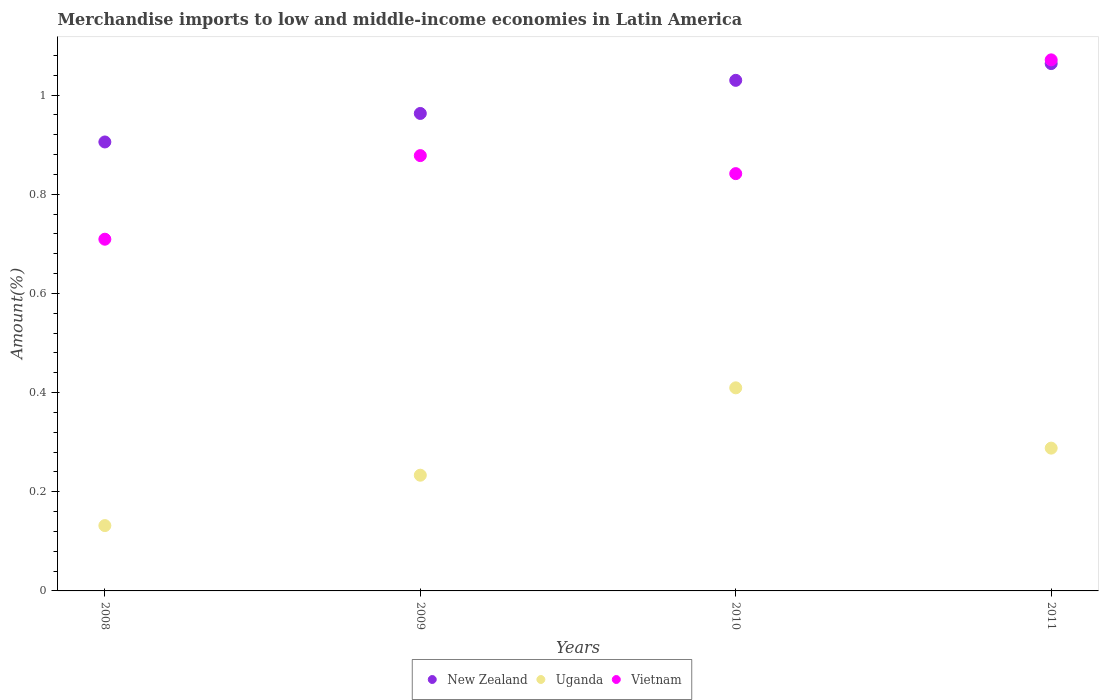Is the number of dotlines equal to the number of legend labels?
Keep it short and to the point. Yes. What is the percentage of amount earned from merchandise imports in Uganda in 2008?
Your answer should be very brief. 0.13. Across all years, what is the maximum percentage of amount earned from merchandise imports in New Zealand?
Keep it short and to the point. 1.06. Across all years, what is the minimum percentage of amount earned from merchandise imports in Vietnam?
Provide a short and direct response. 0.71. In which year was the percentage of amount earned from merchandise imports in New Zealand maximum?
Ensure brevity in your answer.  2011. In which year was the percentage of amount earned from merchandise imports in New Zealand minimum?
Ensure brevity in your answer.  2008. What is the total percentage of amount earned from merchandise imports in Uganda in the graph?
Provide a succinct answer. 1.06. What is the difference between the percentage of amount earned from merchandise imports in New Zealand in 2008 and that in 2009?
Offer a very short reply. -0.06. What is the difference between the percentage of amount earned from merchandise imports in Uganda in 2011 and the percentage of amount earned from merchandise imports in Vietnam in 2009?
Give a very brief answer. -0.59. What is the average percentage of amount earned from merchandise imports in New Zealand per year?
Your response must be concise. 0.99. In the year 2008, what is the difference between the percentage of amount earned from merchandise imports in Vietnam and percentage of amount earned from merchandise imports in Uganda?
Ensure brevity in your answer.  0.58. What is the ratio of the percentage of amount earned from merchandise imports in Uganda in 2009 to that in 2011?
Your answer should be very brief. 0.81. Is the difference between the percentage of amount earned from merchandise imports in Vietnam in 2008 and 2009 greater than the difference between the percentage of amount earned from merchandise imports in Uganda in 2008 and 2009?
Provide a short and direct response. No. What is the difference between the highest and the second highest percentage of amount earned from merchandise imports in Vietnam?
Offer a very short reply. 0.19. What is the difference between the highest and the lowest percentage of amount earned from merchandise imports in Uganda?
Your response must be concise. 0.28. In how many years, is the percentage of amount earned from merchandise imports in Uganda greater than the average percentage of amount earned from merchandise imports in Uganda taken over all years?
Ensure brevity in your answer.  2. Is the sum of the percentage of amount earned from merchandise imports in New Zealand in 2008 and 2010 greater than the maximum percentage of amount earned from merchandise imports in Vietnam across all years?
Your answer should be compact. Yes. Does the percentage of amount earned from merchandise imports in New Zealand monotonically increase over the years?
Provide a succinct answer. Yes. How many dotlines are there?
Ensure brevity in your answer.  3. How many years are there in the graph?
Ensure brevity in your answer.  4. What is the difference between two consecutive major ticks on the Y-axis?
Give a very brief answer. 0.2. Does the graph contain any zero values?
Ensure brevity in your answer.  No. Where does the legend appear in the graph?
Your answer should be compact. Bottom center. How many legend labels are there?
Provide a succinct answer. 3. What is the title of the graph?
Offer a terse response. Merchandise imports to low and middle-income economies in Latin America. Does "Congo (Democratic)" appear as one of the legend labels in the graph?
Keep it short and to the point. No. What is the label or title of the Y-axis?
Give a very brief answer. Amount(%). What is the Amount(%) in New Zealand in 2008?
Ensure brevity in your answer.  0.91. What is the Amount(%) of Uganda in 2008?
Give a very brief answer. 0.13. What is the Amount(%) in Vietnam in 2008?
Offer a terse response. 0.71. What is the Amount(%) of New Zealand in 2009?
Offer a very short reply. 0.96. What is the Amount(%) of Uganda in 2009?
Your answer should be very brief. 0.23. What is the Amount(%) in Vietnam in 2009?
Keep it short and to the point. 0.88. What is the Amount(%) of New Zealand in 2010?
Your answer should be compact. 1.03. What is the Amount(%) in Uganda in 2010?
Offer a terse response. 0.41. What is the Amount(%) in Vietnam in 2010?
Provide a short and direct response. 0.84. What is the Amount(%) of New Zealand in 2011?
Provide a short and direct response. 1.06. What is the Amount(%) of Uganda in 2011?
Give a very brief answer. 0.29. What is the Amount(%) in Vietnam in 2011?
Your response must be concise. 1.07. Across all years, what is the maximum Amount(%) in New Zealand?
Provide a short and direct response. 1.06. Across all years, what is the maximum Amount(%) of Uganda?
Your answer should be very brief. 0.41. Across all years, what is the maximum Amount(%) of Vietnam?
Provide a succinct answer. 1.07. Across all years, what is the minimum Amount(%) of New Zealand?
Offer a very short reply. 0.91. Across all years, what is the minimum Amount(%) of Uganda?
Your answer should be compact. 0.13. Across all years, what is the minimum Amount(%) of Vietnam?
Keep it short and to the point. 0.71. What is the total Amount(%) of New Zealand in the graph?
Your answer should be very brief. 3.96. What is the total Amount(%) in Uganda in the graph?
Your answer should be very brief. 1.06. What is the total Amount(%) of Vietnam in the graph?
Your answer should be compact. 3.5. What is the difference between the Amount(%) in New Zealand in 2008 and that in 2009?
Provide a succinct answer. -0.06. What is the difference between the Amount(%) in Uganda in 2008 and that in 2009?
Your answer should be compact. -0.1. What is the difference between the Amount(%) of Vietnam in 2008 and that in 2009?
Make the answer very short. -0.17. What is the difference between the Amount(%) of New Zealand in 2008 and that in 2010?
Offer a very short reply. -0.12. What is the difference between the Amount(%) of Uganda in 2008 and that in 2010?
Keep it short and to the point. -0.28. What is the difference between the Amount(%) of Vietnam in 2008 and that in 2010?
Make the answer very short. -0.13. What is the difference between the Amount(%) in New Zealand in 2008 and that in 2011?
Offer a terse response. -0.16. What is the difference between the Amount(%) in Uganda in 2008 and that in 2011?
Your answer should be compact. -0.16. What is the difference between the Amount(%) in Vietnam in 2008 and that in 2011?
Offer a terse response. -0.36. What is the difference between the Amount(%) of New Zealand in 2009 and that in 2010?
Provide a succinct answer. -0.07. What is the difference between the Amount(%) of Uganda in 2009 and that in 2010?
Give a very brief answer. -0.18. What is the difference between the Amount(%) in Vietnam in 2009 and that in 2010?
Keep it short and to the point. 0.04. What is the difference between the Amount(%) in New Zealand in 2009 and that in 2011?
Provide a short and direct response. -0.1. What is the difference between the Amount(%) of Uganda in 2009 and that in 2011?
Your response must be concise. -0.05. What is the difference between the Amount(%) of Vietnam in 2009 and that in 2011?
Offer a very short reply. -0.19. What is the difference between the Amount(%) of New Zealand in 2010 and that in 2011?
Give a very brief answer. -0.03. What is the difference between the Amount(%) in Uganda in 2010 and that in 2011?
Offer a terse response. 0.12. What is the difference between the Amount(%) of Vietnam in 2010 and that in 2011?
Your answer should be very brief. -0.23. What is the difference between the Amount(%) of New Zealand in 2008 and the Amount(%) of Uganda in 2009?
Keep it short and to the point. 0.67. What is the difference between the Amount(%) in New Zealand in 2008 and the Amount(%) in Vietnam in 2009?
Offer a terse response. 0.03. What is the difference between the Amount(%) of Uganda in 2008 and the Amount(%) of Vietnam in 2009?
Your response must be concise. -0.75. What is the difference between the Amount(%) of New Zealand in 2008 and the Amount(%) of Uganda in 2010?
Offer a very short reply. 0.5. What is the difference between the Amount(%) of New Zealand in 2008 and the Amount(%) of Vietnam in 2010?
Keep it short and to the point. 0.06. What is the difference between the Amount(%) in Uganda in 2008 and the Amount(%) in Vietnam in 2010?
Ensure brevity in your answer.  -0.71. What is the difference between the Amount(%) in New Zealand in 2008 and the Amount(%) in Uganda in 2011?
Keep it short and to the point. 0.62. What is the difference between the Amount(%) of New Zealand in 2008 and the Amount(%) of Vietnam in 2011?
Ensure brevity in your answer.  -0.17. What is the difference between the Amount(%) of Uganda in 2008 and the Amount(%) of Vietnam in 2011?
Provide a short and direct response. -0.94. What is the difference between the Amount(%) in New Zealand in 2009 and the Amount(%) in Uganda in 2010?
Your response must be concise. 0.55. What is the difference between the Amount(%) in New Zealand in 2009 and the Amount(%) in Vietnam in 2010?
Your answer should be very brief. 0.12. What is the difference between the Amount(%) of Uganda in 2009 and the Amount(%) of Vietnam in 2010?
Make the answer very short. -0.61. What is the difference between the Amount(%) in New Zealand in 2009 and the Amount(%) in Uganda in 2011?
Ensure brevity in your answer.  0.68. What is the difference between the Amount(%) of New Zealand in 2009 and the Amount(%) of Vietnam in 2011?
Ensure brevity in your answer.  -0.11. What is the difference between the Amount(%) of Uganda in 2009 and the Amount(%) of Vietnam in 2011?
Your answer should be very brief. -0.84. What is the difference between the Amount(%) in New Zealand in 2010 and the Amount(%) in Uganda in 2011?
Your answer should be very brief. 0.74. What is the difference between the Amount(%) of New Zealand in 2010 and the Amount(%) of Vietnam in 2011?
Offer a terse response. -0.04. What is the difference between the Amount(%) in Uganda in 2010 and the Amount(%) in Vietnam in 2011?
Give a very brief answer. -0.66. What is the average Amount(%) of New Zealand per year?
Your answer should be compact. 0.99. What is the average Amount(%) in Uganda per year?
Ensure brevity in your answer.  0.27. What is the average Amount(%) of Vietnam per year?
Your answer should be very brief. 0.88. In the year 2008, what is the difference between the Amount(%) of New Zealand and Amount(%) of Uganda?
Make the answer very short. 0.77. In the year 2008, what is the difference between the Amount(%) in New Zealand and Amount(%) in Vietnam?
Make the answer very short. 0.2. In the year 2008, what is the difference between the Amount(%) in Uganda and Amount(%) in Vietnam?
Your answer should be compact. -0.58. In the year 2009, what is the difference between the Amount(%) of New Zealand and Amount(%) of Uganda?
Ensure brevity in your answer.  0.73. In the year 2009, what is the difference between the Amount(%) in New Zealand and Amount(%) in Vietnam?
Provide a succinct answer. 0.09. In the year 2009, what is the difference between the Amount(%) of Uganda and Amount(%) of Vietnam?
Offer a very short reply. -0.64. In the year 2010, what is the difference between the Amount(%) in New Zealand and Amount(%) in Uganda?
Provide a succinct answer. 0.62. In the year 2010, what is the difference between the Amount(%) in New Zealand and Amount(%) in Vietnam?
Make the answer very short. 0.19. In the year 2010, what is the difference between the Amount(%) of Uganda and Amount(%) of Vietnam?
Your answer should be compact. -0.43. In the year 2011, what is the difference between the Amount(%) of New Zealand and Amount(%) of Uganda?
Provide a short and direct response. 0.78. In the year 2011, what is the difference between the Amount(%) in New Zealand and Amount(%) in Vietnam?
Keep it short and to the point. -0.01. In the year 2011, what is the difference between the Amount(%) of Uganda and Amount(%) of Vietnam?
Provide a succinct answer. -0.78. What is the ratio of the Amount(%) of New Zealand in 2008 to that in 2009?
Offer a terse response. 0.94. What is the ratio of the Amount(%) in Uganda in 2008 to that in 2009?
Offer a very short reply. 0.56. What is the ratio of the Amount(%) in Vietnam in 2008 to that in 2009?
Offer a very short reply. 0.81. What is the ratio of the Amount(%) in New Zealand in 2008 to that in 2010?
Keep it short and to the point. 0.88. What is the ratio of the Amount(%) of Uganda in 2008 to that in 2010?
Make the answer very short. 0.32. What is the ratio of the Amount(%) of Vietnam in 2008 to that in 2010?
Your response must be concise. 0.84. What is the ratio of the Amount(%) in New Zealand in 2008 to that in 2011?
Make the answer very short. 0.85. What is the ratio of the Amount(%) in Uganda in 2008 to that in 2011?
Ensure brevity in your answer.  0.46. What is the ratio of the Amount(%) in Vietnam in 2008 to that in 2011?
Provide a succinct answer. 0.66. What is the ratio of the Amount(%) in New Zealand in 2009 to that in 2010?
Provide a short and direct response. 0.94. What is the ratio of the Amount(%) in Uganda in 2009 to that in 2010?
Provide a short and direct response. 0.57. What is the ratio of the Amount(%) in Vietnam in 2009 to that in 2010?
Ensure brevity in your answer.  1.04. What is the ratio of the Amount(%) of New Zealand in 2009 to that in 2011?
Your answer should be very brief. 0.91. What is the ratio of the Amount(%) of Uganda in 2009 to that in 2011?
Your answer should be very brief. 0.81. What is the ratio of the Amount(%) of Vietnam in 2009 to that in 2011?
Offer a very short reply. 0.82. What is the ratio of the Amount(%) of New Zealand in 2010 to that in 2011?
Offer a terse response. 0.97. What is the ratio of the Amount(%) of Uganda in 2010 to that in 2011?
Provide a succinct answer. 1.42. What is the ratio of the Amount(%) in Vietnam in 2010 to that in 2011?
Provide a succinct answer. 0.79. What is the difference between the highest and the second highest Amount(%) in New Zealand?
Your answer should be compact. 0.03. What is the difference between the highest and the second highest Amount(%) of Uganda?
Offer a very short reply. 0.12. What is the difference between the highest and the second highest Amount(%) of Vietnam?
Your answer should be compact. 0.19. What is the difference between the highest and the lowest Amount(%) of New Zealand?
Offer a very short reply. 0.16. What is the difference between the highest and the lowest Amount(%) in Uganda?
Ensure brevity in your answer.  0.28. What is the difference between the highest and the lowest Amount(%) of Vietnam?
Provide a succinct answer. 0.36. 